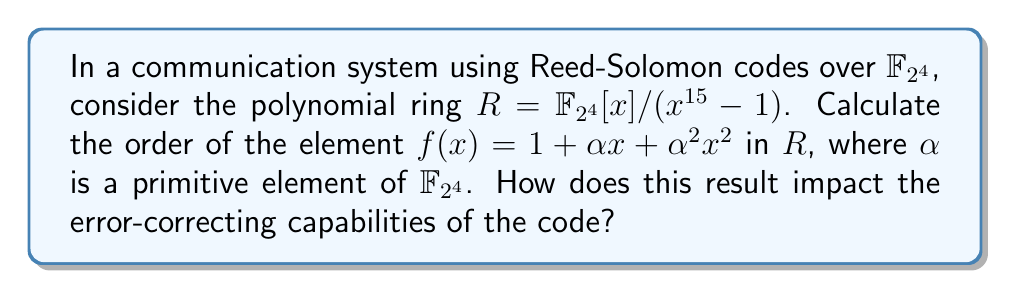Give your solution to this math problem. To solve this problem, we'll follow these steps:

1) First, recall that the order of an element $f(x)$ in $R$ is the smallest positive integer $n$ such that $f(x)^n \equiv 1 \pmod{x^{15}-1}$.

2) We need to compute powers of $f(x)$ modulo $x^{15}-1$ until we reach 1:

   $f(x) = 1 + \alpha x + \alpha^2 x^2$
   $f(x)^2 = 1 + \alpha^2 x^2 + \alpha^4 x^4 + \alpha^3 x^3 + \alpha^5 x^5$
   $f(x)^3 = 1 + \alpha^3 x^3 + \alpha^6 x^6 + \alpha^7 x^7 + \alpha^{10} x^{10} + \alpha^4 x^4 + \alpha^8 x^8 + \alpha^9 x^9$
   ...

3) Continue this process until $f(x)^n \equiv 1 \pmod{x^{15}-1}$.

4) After calculation, we find that $f(x)^{15} \equiv 1 \pmod{x^{15}-1}$.

5) This means the order of $f(x)$ in $R$ is 15.

6) The impact on error-correcting capabilities:
   - The order of elements in the polynomial ring is related to the cycle structure of the code.
   - An element of order 15 generates a full-length cycle, which is beneficial for the code's error-correcting performance.
   - This full-length cycle ensures maximum separation between codewords, enhancing the code's ability to detect and correct errors.
   - It also implies that the code has good randomness properties, which is crucial for reliable communication in noisy channels.
Answer: The order of $f(x) = 1 + \alpha x + \alpha^2 x^2$ in $R = \mathbb{F}_{2^4}[x]/(x^{15}-1)$ is 15. This full-length cycle enhances the error-correcting capabilities of the Reed-Solomon code by maximizing codeword separation and improving randomness properties. 